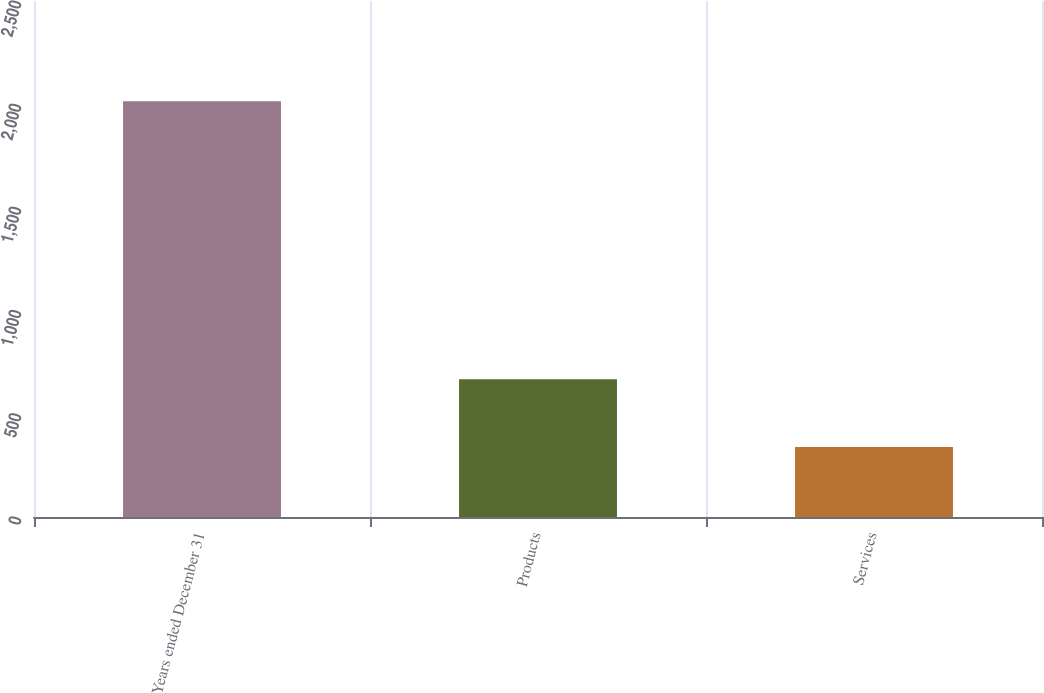Convert chart to OTSL. <chart><loc_0><loc_0><loc_500><loc_500><bar_chart><fcel>Years ended December 31<fcel>Products<fcel>Services<nl><fcel>2014<fcel>667<fcel>339<nl></chart> 